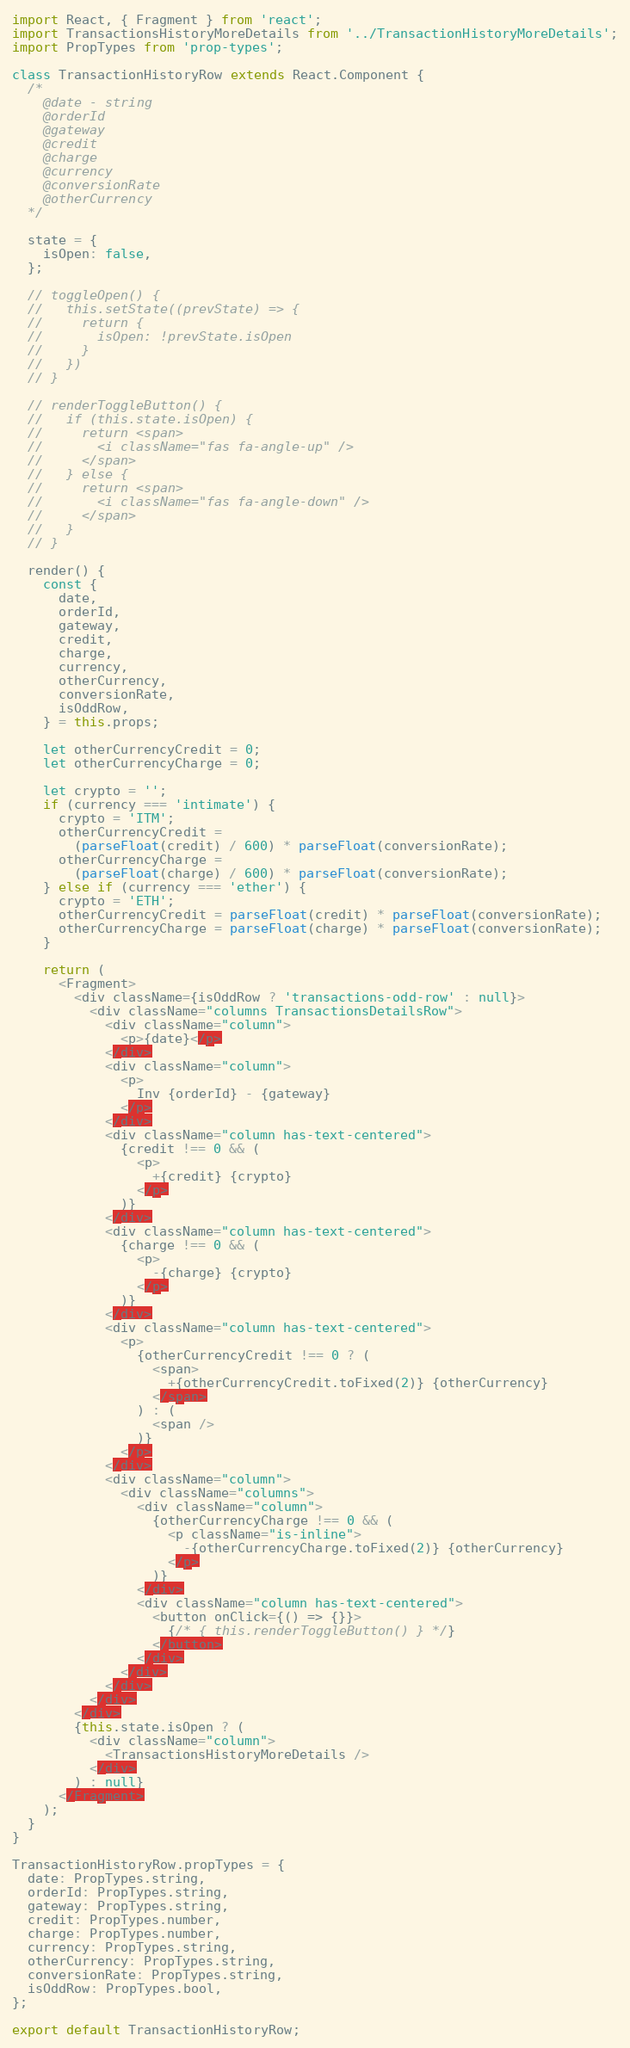<code> <loc_0><loc_0><loc_500><loc_500><_JavaScript_>import React, { Fragment } from 'react';
import TransactionsHistoryMoreDetails from '../TransactionHistoryMoreDetails';
import PropTypes from 'prop-types';

class TransactionHistoryRow extends React.Component {
  /*
    @date - string
    @orderId
    @gateway
    @credit
    @charge
    @currency
    @conversionRate
    @otherCurrency
  */

  state = {
    isOpen: false,
  };

  // toggleOpen() {
  //   this.setState((prevState) => {
  //     return {
  //       isOpen: !prevState.isOpen
  //     }
  //   })
  // }

  // renderToggleButton() {
  //   if (this.state.isOpen) {
  //     return <span>
  //       <i className="fas fa-angle-up" />
  //     </span>
  //   } else {
  //     return <span>
  //       <i className="fas fa-angle-down" />
  //     </span>
  //   }
  // }

  render() {
    const {
      date,
      orderId,
      gateway,
      credit,
      charge,
      currency,
      otherCurrency,
      conversionRate,
      isOddRow,
    } = this.props;

    let otherCurrencyCredit = 0;
    let otherCurrencyCharge = 0;

    let crypto = '';
    if (currency === 'intimate') {
      crypto = 'ITM';
      otherCurrencyCredit =
        (parseFloat(credit) / 600) * parseFloat(conversionRate);
      otherCurrencyCharge =
        (parseFloat(charge) / 600) * parseFloat(conversionRate);
    } else if (currency === 'ether') {
      crypto = 'ETH';
      otherCurrencyCredit = parseFloat(credit) * parseFloat(conversionRate);
      otherCurrencyCharge = parseFloat(charge) * parseFloat(conversionRate);
    }

    return (
      <Fragment>
        <div className={isOddRow ? 'transactions-odd-row' : null}>
          <div className="columns TransactionsDetailsRow">
            <div className="column">
              <p>{date}</p>
            </div>
            <div className="column">
              <p>
                Inv {orderId} - {gateway}
              </p>
            </div>
            <div className="column has-text-centered">
              {credit !== 0 && (
                <p>
                  +{credit} {crypto}
                </p>
              )}
            </div>
            <div className="column has-text-centered">
              {charge !== 0 && (
                <p>
                  -{charge} {crypto}
                </p>
              )}
            </div>
            <div className="column has-text-centered">
              <p>
                {otherCurrencyCredit !== 0 ? (
                  <span>
                    +{otherCurrencyCredit.toFixed(2)} {otherCurrency}
                  </span>
                ) : (
                  <span />
                )}
              </p>
            </div>
            <div className="column">
              <div className="columns">
                <div className="column">
                  {otherCurrencyCharge !== 0 && (
                    <p className="is-inline">
                      -{otherCurrencyCharge.toFixed(2)} {otherCurrency}
                    </p>
                  )}
                </div>
                <div className="column has-text-centered">
                  <button onClick={() => {}}>
                    {/* { this.renderToggleButton() } */}
                  </button>
                </div>
              </div>
            </div>
          </div>
        </div>
        {this.state.isOpen ? (
          <div className="column">
            <TransactionsHistoryMoreDetails />
          </div>
        ) : null}
      </Fragment>
    );
  }
}

TransactionHistoryRow.propTypes = {
  date: PropTypes.string,
  orderId: PropTypes.string,
  gateway: PropTypes.string,
  credit: PropTypes.number,
  charge: PropTypes.number,
  currency: PropTypes.string,
  otherCurrency: PropTypes.string,
  conversionRate: PropTypes.string,
  isOddRow: PropTypes.bool,
};

export default TransactionHistoryRow;
</code> 